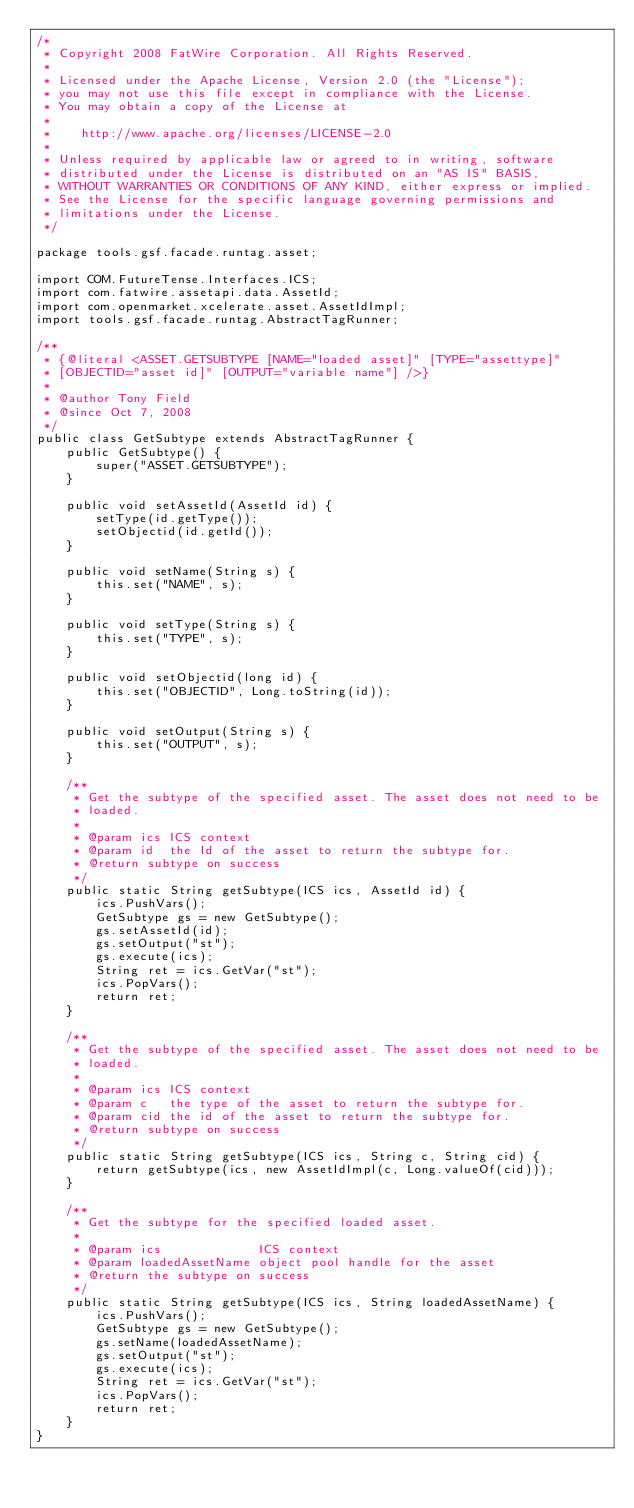Convert code to text. <code><loc_0><loc_0><loc_500><loc_500><_Java_>/*
 * Copyright 2008 FatWire Corporation. All Rights Reserved.
 *
 * Licensed under the Apache License, Version 2.0 (the "License");
 * you may not use this file except in compliance with the License.
 * You may obtain a copy of the License at
 *
 *    http://www.apache.org/licenses/LICENSE-2.0
 *
 * Unless required by applicable law or agreed to in writing, software
 * distributed under the License is distributed on an "AS IS" BASIS,
 * WITHOUT WARRANTIES OR CONDITIONS OF ANY KIND, either express or implied.
 * See the License for the specific language governing permissions and
 * limitations under the License.
 */

package tools.gsf.facade.runtag.asset;

import COM.FutureTense.Interfaces.ICS;
import com.fatwire.assetapi.data.AssetId;
import com.openmarket.xcelerate.asset.AssetIdImpl;
import tools.gsf.facade.runtag.AbstractTagRunner;

/**
 * {@literal <ASSET.GETSUBTYPE [NAME="loaded asset]" [TYPE="assettype]"
 * [OBJECTID="asset id]" [OUTPUT="variable name"] />}
 *
 * @author Tony Field
 * @since Oct 7, 2008
 */
public class GetSubtype extends AbstractTagRunner {
    public GetSubtype() {
        super("ASSET.GETSUBTYPE");
    }

    public void setAssetId(AssetId id) {
        setType(id.getType());
        setObjectid(id.getId());
    }

    public void setName(String s) {
        this.set("NAME", s);
    }

    public void setType(String s) {
        this.set("TYPE", s);
    }

    public void setObjectid(long id) {
        this.set("OBJECTID", Long.toString(id));
    }

    public void setOutput(String s) {
        this.set("OUTPUT", s);
    }

    /**
     * Get the subtype of the specified asset. The asset does not need to be
     * loaded.
     *
     * @param ics ICS context
     * @param id  the Id of the asset to return the subtype for.
     * @return subtype on success
     */
    public static String getSubtype(ICS ics, AssetId id) {
        ics.PushVars();
        GetSubtype gs = new GetSubtype();
        gs.setAssetId(id);
        gs.setOutput("st");
        gs.execute(ics);
        String ret = ics.GetVar("st");
        ics.PopVars();
        return ret;
    }

    /**
     * Get the subtype of the specified asset. The asset does not need to be
     * loaded.
     *
     * @param ics ICS context
     * @param c   the type of the asset to return the subtype for.
     * @param cid the id of the asset to return the subtype for.
     * @return subtype on success
     */
    public static String getSubtype(ICS ics, String c, String cid) {
        return getSubtype(ics, new AssetIdImpl(c, Long.valueOf(cid)));
    }

    /**
     * Get the subtype for the specified loaded asset.
     *
     * @param ics             ICS context
     * @param loadedAssetName object pool handle for the asset
     * @return the subtype on success
     */
    public static String getSubtype(ICS ics, String loadedAssetName) {
        ics.PushVars();
        GetSubtype gs = new GetSubtype();
        gs.setName(loadedAssetName);
        gs.setOutput("st");
        gs.execute(ics);
        String ret = ics.GetVar("st");
        ics.PopVars();
        return ret;
    }
}
</code> 